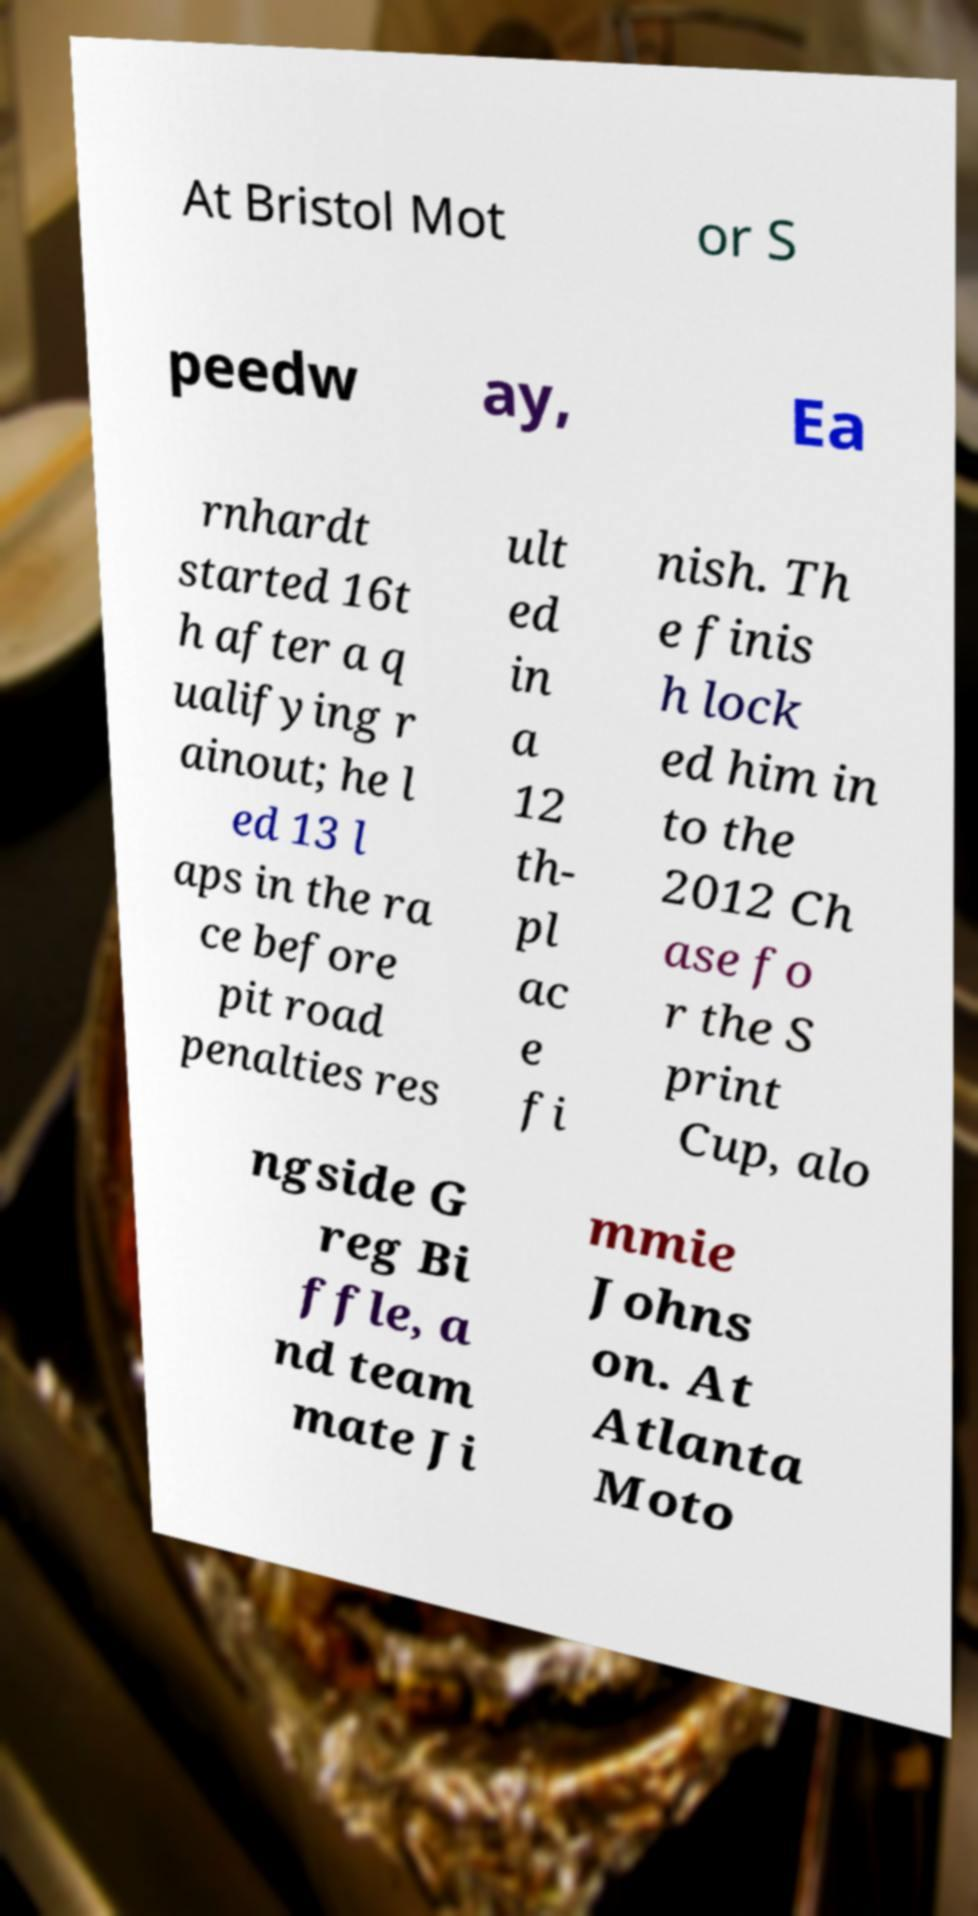For documentation purposes, I need the text within this image transcribed. Could you provide that? At Bristol Mot or S peedw ay, Ea rnhardt started 16t h after a q ualifying r ainout; he l ed 13 l aps in the ra ce before pit road penalties res ult ed in a 12 th- pl ac e fi nish. Th e finis h lock ed him in to the 2012 Ch ase fo r the S print Cup, alo ngside G reg Bi ffle, a nd team mate Ji mmie Johns on. At Atlanta Moto 